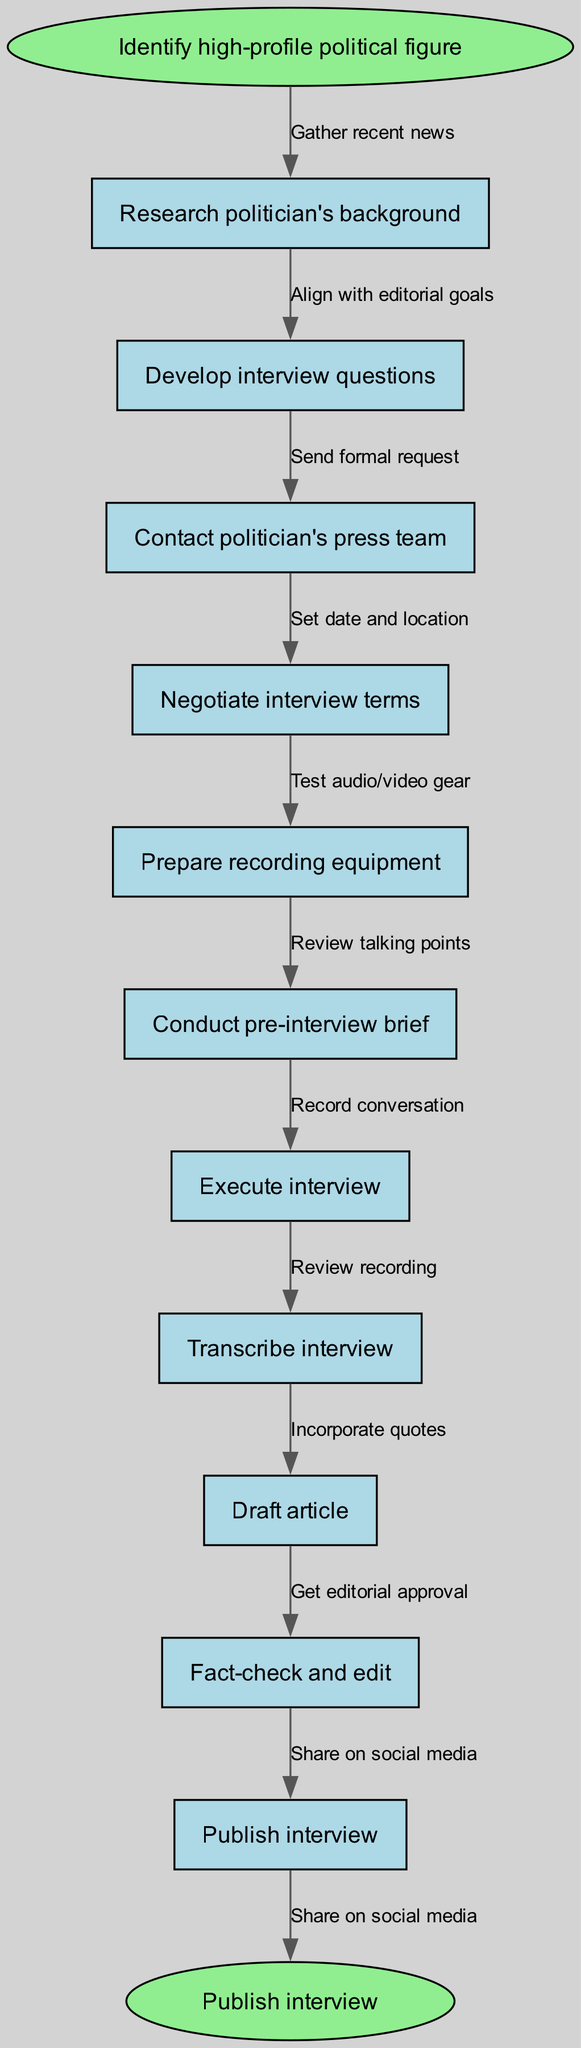What is the first step in the diagram? The first step is indicated by the starting node labeled "Identify high-profile political figure," which shows the initial action in the sequence.
Answer: Identify high-profile political figure How many nodes are in the diagram? The diagram contains 12 nodes, including the starting and ending nodes, counting each distinct step involved in the process.
Answer: 12 What is the last step before publishing the interview? The last step before publishing is "Fact-check and edit," which appears immediately before the final action of publishing the interview.
Answer: Fact-check and edit Which node follows "Negotiate interview terms"? The node that directly follows "Negotiate interview terms" is "Prepare recording equipment," established by the flow of edges connecting the nodes.
Answer: Prepare recording equipment What is the edge connecting "Execute interview" to the next node? The edge connecting "Execute interview" to the next node is labeled "Record conversation," indicating the action taken immediately after the interview is executed.
Answer: Record conversation What is the purpose of the node labeled "Transcribe interview"? The purpose of the node labeled "Transcribe interview" is to indicate the action of converting the recorded conversation into written text, which is a necessary step before drafting the article.
Answer: Convert recorded conversation into written text What is the relationship between "Contact politician's press team" and "Negotiate interview terms"? The relationship is sequential; "Contact politician's press team" occurs first, leading into "Negotiate interview terms," establishing a process where contacting initiates the negotiation phase.
Answer: Sequential relationship What does the last edge lead to in the diagram? The last edge leads to the node labeled "Publish interview," which signifies the final action taken after all previous steps have been completed.
Answer: Publish interview Which node comes after "Prepare recording equipment"? The node that comes after "Prepare recording equipment" is "Conduct pre-interview brief," which follows logically as preparation leads to briefing.
Answer: Conduct pre-interview brief 